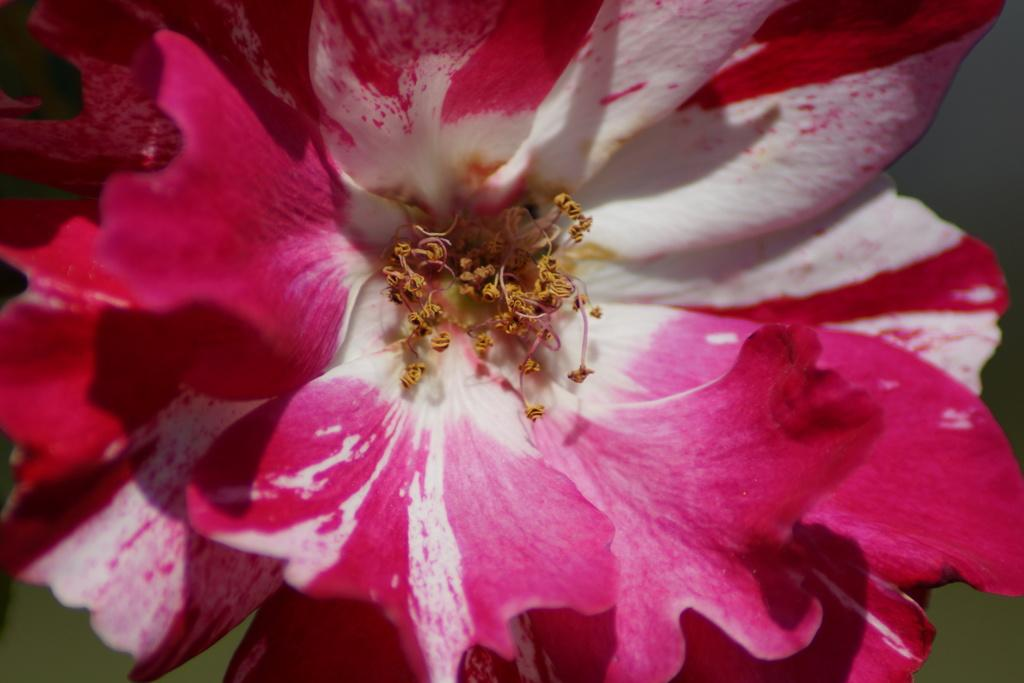What type of flower can be seen in the image? There is a pink color flower in the image. What type of train is visible in the background of the image? There is no train present in the image; it only features a pink color flower. 